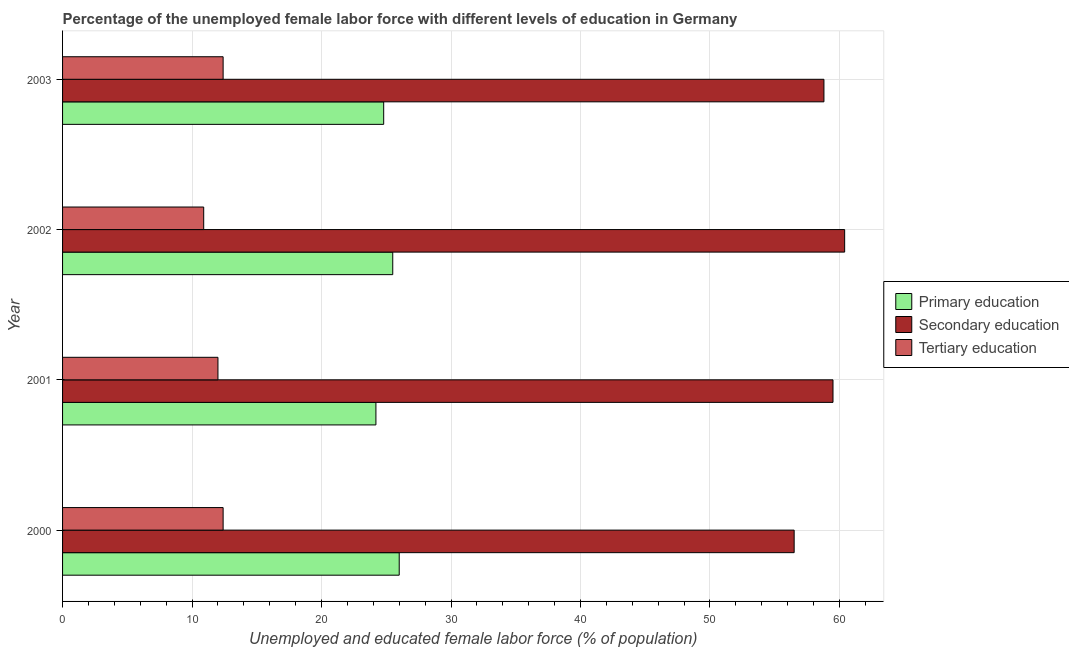How many different coloured bars are there?
Your answer should be compact. 3. How many groups of bars are there?
Your answer should be very brief. 4. Are the number of bars on each tick of the Y-axis equal?
Provide a succinct answer. Yes. What is the percentage of female labor force who received primary education in 2001?
Your response must be concise. 24.2. Across all years, what is the maximum percentage of female labor force who received primary education?
Make the answer very short. 26. Across all years, what is the minimum percentage of female labor force who received secondary education?
Offer a very short reply. 56.5. In which year was the percentage of female labor force who received secondary education minimum?
Provide a short and direct response. 2000. What is the total percentage of female labor force who received tertiary education in the graph?
Your answer should be compact. 47.7. What is the difference between the percentage of female labor force who received primary education in 2003 and the percentage of female labor force who received tertiary education in 2000?
Offer a terse response. 12.4. What is the average percentage of female labor force who received primary education per year?
Your response must be concise. 25.12. In the year 2003, what is the difference between the percentage of female labor force who received secondary education and percentage of female labor force who received tertiary education?
Ensure brevity in your answer.  46.4. In how many years, is the percentage of female labor force who received secondary education greater than 26 %?
Offer a terse response. 4. What is the ratio of the percentage of female labor force who received primary education in 2001 to that in 2003?
Ensure brevity in your answer.  0.98. Is the difference between the percentage of female labor force who received tertiary education in 2001 and 2002 greater than the difference between the percentage of female labor force who received primary education in 2001 and 2002?
Ensure brevity in your answer.  Yes. In how many years, is the percentage of female labor force who received secondary education greater than the average percentage of female labor force who received secondary education taken over all years?
Your answer should be very brief. 2. What does the 3rd bar from the top in 2003 represents?
Your answer should be compact. Primary education. What does the 3rd bar from the bottom in 2000 represents?
Give a very brief answer. Tertiary education. Is it the case that in every year, the sum of the percentage of female labor force who received primary education and percentage of female labor force who received secondary education is greater than the percentage of female labor force who received tertiary education?
Offer a terse response. Yes. Are the values on the major ticks of X-axis written in scientific E-notation?
Provide a succinct answer. No. Does the graph contain any zero values?
Offer a very short reply. No. How many legend labels are there?
Your answer should be compact. 3. What is the title of the graph?
Your response must be concise. Percentage of the unemployed female labor force with different levels of education in Germany. Does "Tertiary education" appear as one of the legend labels in the graph?
Ensure brevity in your answer.  Yes. What is the label or title of the X-axis?
Give a very brief answer. Unemployed and educated female labor force (% of population). What is the label or title of the Y-axis?
Give a very brief answer. Year. What is the Unemployed and educated female labor force (% of population) of Primary education in 2000?
Your answer should be compact. 26. What is the Unemployed and educated female labor force (% of population) of Secondary education in 2000?
Offer a very short reply. 56.5. What is the Unemployed and educated female labor force (% of population) in Tertiary education in 2000?
Your response must be concise. 12.4. What is the Unemployed and educated female labor force (% of population) of Primary education in 2001?
Provide a short and direct response. 24.2. What is the Unemployed and educated female labor force (% of population) in Secondary education in 2001?
Make the answer very short. 59.5. What is the Unemployed and educated female labor force (% of population) of Secondary education in 2002?
Your response must be concise. 60.4. What is the Unemployed and educated female labor force (% of population) of Tertiary education in 2002?
Provide a succinct answer. 10.9. What is the Unemployed and educated female labor force (% of population) in Primary education in 2003?
Provide a succinct answer. 24.8. What is the Unemployed and educated female labor force (% of population) of Secondary education in 2003?
Provide a succinct answer. 58.8. What is the Unemployed and educated female labor force (% of population) in Tertiary education in 2003?
Give a very brief answer. 12.4. Across all years, what is the maximum Unemployed and educated female labor force (% of population) in Primary education?
Your answer should be very brief. 26. Across all years, what is the maximum Unemployed and educated female labor force (% of population) in Secondary education?
Ensure brevity in your answer.  60.4. Across all years, what is the maximum Unemployed and educated female labor force (% of population) in Tertiary education?
Give a very brief answer. 12.4. Across all years, what is the minimum Unemployed and educated female labor force (% of population) of Primary education?
Your response must be concise. 24.2. Across all years, what is the minimum Unemployed and educated female labor force (% of population) of Secondary education?
Give a very brief answer. 56.5. Across all years, what is the minimum Unemployed and educated female labor force (% of population) in Tertiary education?
Keep it short and to the point. 10.9. What is the total Unemployed and educated female labor force (% of population) of Primary education in the graph?
Make the answer very short. 100.5. What is the total Unemployed and educated female labor force (% of population) of Secondary education in the graph?
Keep it short and to the point. 235.2. What is the total Unemployed and educated female labor force (% of population) of Tertiary education in the graph?
Your response must be concise. 47.7. What is the difference between the Unemployed and educated female labor force (% of population) of Secondary education in 2000 and that in 2003?
Your answer should be compact. -2.3. What is the difference between the Unemployed and educated female labor force (% of population) in Primary education in 2001 and that in 2002?
Offer a very short reply. -1.3. What is the difference between the Unemployed and educated female labor force (% of population) in Secondary education in 2001 and that in 2002?
Offer a terse response. -0.9. What is the difference between the Unemployed and educated female labor force (% of population) in Primary education in 2000 and the Unemployed and educated female labor force (% of population) in Secondary education in 2001?
Offer a terse response. -33.5. What is the difference between the Unemployed and educated female labor force (% of population) in Primary education in 2000 and the Unemployed and educated female labor force (% of population) in Tertiary education in 2001?
Your answer should be very brief. 14. What is the difference between the Unemployed and educated female labor force (% of population) of Secondary education in 2000 and the Unemployed and educated female labor force (% of population) of Tertiary education in 2001?
Provide a short and direct response. 44.5. What is the difference between the Unemployed and educated female labor force (% of population) in Primary education in 2000 and the Unemployed and educated female labor force (% of population) in Secondary education in 2002?
Provide a short and direct response. -34.4. What is the difference between the Unemployed and educated female labor force (% of population) of Primary education in 2000 and the Unemployed and educated female labor force (% of population) of Tertiary education in 2002?
Your answer should be compact. 15.1. What is the difference between the Unemployed and educated female labor force (% of population) of Secondary education in 2000 and the Unemployed and educated female labor force (% of population) of Tertiary education in 2002?
Your answer should be compact. 45.6. What is the difference between the Unemployed and educated female labor force (% of population) in Primary education in 2000 and the Unemployed and educated female labor force (% of population) in Secondary education in 2003?
Provide a succinct answer. -32.8. What is the difference between the Unemployed and educated female labor force (% of population) of Secondary education in 2000 and the Unemployed and educated female labor force (% of population) of Tertiary education in 2003?
Give a very brief answer. 44.1. What is the difference between the Unemployed and educated female labor force (% of population) in Primary education in 2001 and the Unemployed and educated female labor force (% of population) in Secondary education in 2002?
Keep it short and to the point. -36.2. What is the difference between the Unemployed and educated female labor force (% of population) in Secondary education in 2001 and the Unemployed and educated female labor force (% of population) in Tertiary education in 2002?
Provide a short and direct response. 48.6. What is the difference between the Unemployed and educated female labor force (% of population) of Primary education in 2001 and the Unemployed and educated female labor force (% of population) of Secondary education in 2003?
Offer a terse response. -34.6. What is the difference between the Unemployed and educated female labor force (% of population) in Primary education in 2001 and the Unemployed and educated female labor force (% of population) in Tertiary education in 2003?
Ensure brevity in your answer.  11.8. What is the difference between the Unemployed and educated female labor force (% of population) in Secondary education in 2001 and the Unemployed and educated female labor force (% of population) in Tertiary education in 2003?
Make the answer very short. 47.1. What is the difference between the Unemployed and educated female labor force (% of population) in Primary education in 2002 and the Unemployed and educated female labor force (% of population) in Secondary education in 2003?
Make the answer very short. -33.3. What is the average Unemployed and educated female labor force (% of population) of Primary education per year?
Your answer should be very brief. 25.12. What is the average Unemployed and educated female labor force (% of population) of Secondary education per year?
Offer a terse response. 58.8. What is the average Unemployed and educated female labor force (% of population) of Tertiary education per year?
Ensure brevity in your answer.  11.93. In the year 2000, what is the difference between the Unemployed and educated female labor force (% of population) in Primary education and Unemployed and educated female labor force (% of population) in Secondary education?
Your answer should be compact. -30.5. In the year 2000, what is the difference between the Unemployed and educated female labor force (% of population) of Primary education and Unemployed and educated female labor force (% of population) of Tertiary education?
Provide a succinct answer. 13.6. In the year 2000, what is the difference between the Unemployed and educated female labor force (% of population) in Secondary education and Unemployed and educated female labor force (% of population) in Tertiary education?
Give a very brief answer. 44.1. In the year 2001, what is the difference between the Unemployed and educated female labor force (% of population) in Primary education and Unemployed and educated female labor force (% of population) in Secondary education?
Your answer should be very brief. -35.3. In the year 2001, what is the difference between the Unemployed and educated female labor force (% of population) in Primary education and Unemployed and educated female labor force (% of population) in Tertiary education?
Offer a terse response. 12.2. In the year 2001, what is the difference between the Unemployed and educated female labor force (% of population) of Secondary education and Unemployed and educated female labor force (% of population) of Tertiary education?
Make the answer very short. 47.5. In the year 2002, what is the difference between the Unemployed and educated female labor force (% of population) of Primary education and Unemployed and educated female labor force (% of population) of Secondary education?
Make the answer very short. -34.9. In the year 2002, what is the difference between the Unemployed and educated female labor force (% of population) of Primary education and Unemployed and educated female labor force (% of population) of Tertiary education?
Give a very brief answer. 14.6. In the year 2002, what is the difference between the Unemployed and educated female labor force (% of population) of Secondary education and Unemployed and educated female labor force (% of population) of Tertiary education?
Offer a very short reply. 49.5. In the year 2003, what is the difference between the Unemployed and educated female labor force (% of population) in Primary education and Unemployed and educated female labor force (% of population) in Secondary education?
Keep it short and to the point. -34. In the year 2003, what is the difference between the Unemployed and educated female labor force (% of population) of Secondary education and Unemployed and educated female labor force (% of population) of Tertiary education?
Your answer should be very brief. 46.4. What is the ratio of the Unemployed and educated female labor force (% of population) in Primary education in 2000 to that in 2001?
Offer a very short reply. 1.07. What is the ratio of the Unemployed and educated female labor force (% of population) in Secondary education in 2000 to that in 2001?
Make the answer very short. 0.95. What is the ratio of the Unemployed and educated female labor force (% of population) in Primary education in 2000 to that in 2002?
Make the answer very short. 1.02. What is the ratio of the Unemployed and educated female labor force (% of population) in Secondary education in 2000 to that in 2002?
Give a very brief answer. 0.94. What is the ratio of the Unemployed and educated female labor force (% of population) of Tertiary education in 2000 to that in 2002?
Your answer should be very brief. 1.14. What is the ratio of the Unemployed and educated female labor force (% of population) in Primary education in 2000 to that in 2003?
Offer a very short reply. 1.05. What is the ratio of the Unemployed and educated female labor force (% of population) in Secondary education in 2000 to that in 2003?
Ensure brevity in your answer.  0.96. What is the ratio of the Unemployed and educated female labor force (% of population) in Primary education in 2001 to that in 2002?
Provide a short and direct response. 0.95. What is the ratio of the Unemployed and educated female labor force (% of population) in Secondary education in 2001 to that in 2002?
Your response must be concise. 0.99. What is the ratio of the Unemployed and educated female labor force (% of population) in Tertiary education in 2001 to that in 2002?
Your answer should be compact. 1.1. What is the ratio of the Unemployed and educated female labor force (% of population) of Primary education in 2001 to that in 2003?
Give a very brief answer. 0.98. What is the ratio of the Unemployed and educated female labor force (% of population) of Secondary education in 2001 to that in 2003?
Your answer should be very brief. 1.01. What is the ratio of the Unemployed and educated female labor force (% of population) in Primary education in 2002 to that in 2003?
Ensure brevity in your answer.  1.03. What is the ratio of the Unemployed and educated female labor force (% of population) in Secondary education in 2002 to that in 2003?
Your answer should be very brief. 1.03. What is the ratio of the Unemployed and educated female labor force (% of population) of Tertiary education in 2002 to that in 2003?
Ensure brevity in your answer.  0.88. What is the difference between the highest and the second highest Unemployed and educated female labor force (% of population) in Primary education?
Offer a terse response. 0.5. What is the difference between the highest and the second highest Unemployed and educated female labor force (% of population) in Secondary education?
Give a very brief answer. 0.9. What is the difference between the highest and the second highest Unemployed and educated female labor force (% of population) in Tertiary education?
Your answer should be very brief. 0. What is the difference between the highest and the lowest Unemployed and educated female labor force (% of population) of Primary education?
Make the answer very short. 1.8. What is the difference between the highest and the lowest Unemployed and educated female labor force (% of population) of Secondary education?
Keep it short and to the point. 3.9. What is the difference between the highest and the lowest Unemployed and educated female labor force (% of population) in Tertiary education?
Offer a terse response. 1.5. 